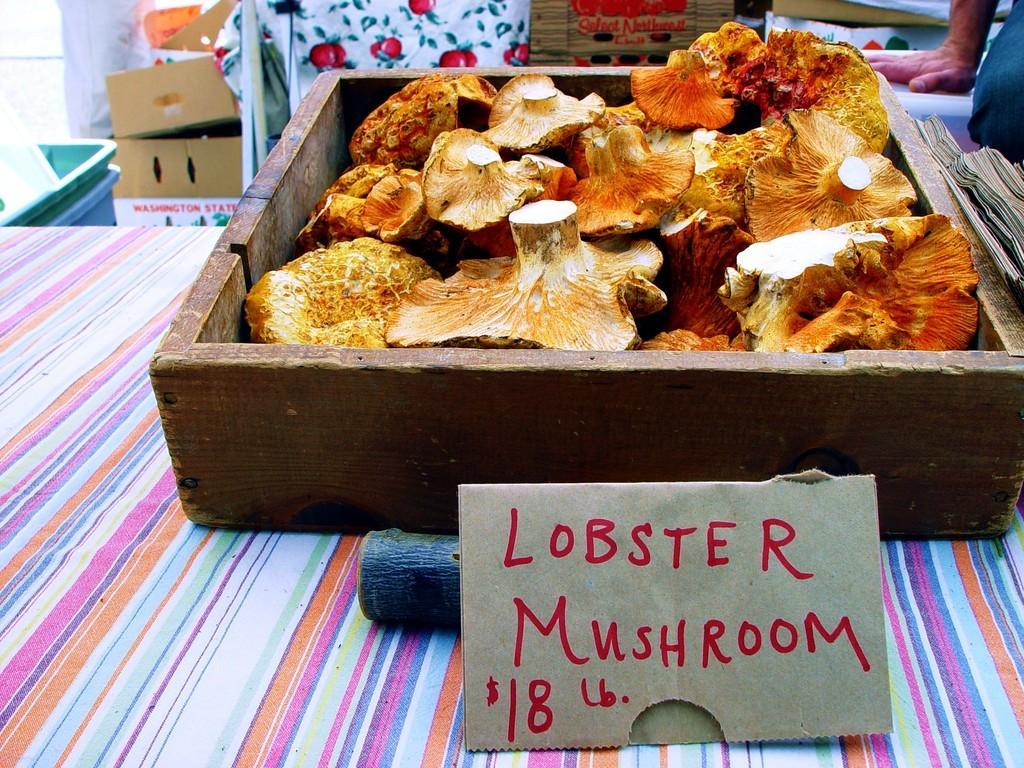Please provide a concise description of this image. In this picture we can see some text, numbers and a symbol on a brown object. There is an object and some food items are visible in the wooden box. This wooden box is visible on a multi colored cloth. We can see the hand and the leg of a person. We can see a few boxes, containers and other objects in the background. 